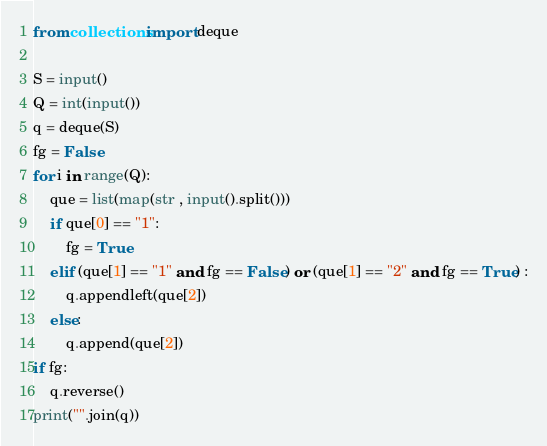<code> <loc_0><loc_0><loc_500><loc_500><_Python_>from collections import deque

S = input()
Q = int(input())
q = deque(S)
fg = False
for i in range(Q):
    que = list(map(str , input().split()))
    if que[0] == "1":
        fg = True
    elif (que[1] == "1" and fg == False) or (que[1] == "2" and fg == True) :
        q.appendleft(que[2])
    else:
        q.append(que[2])
if fg:
    q.reverse()
print("".join(q))
</code> 